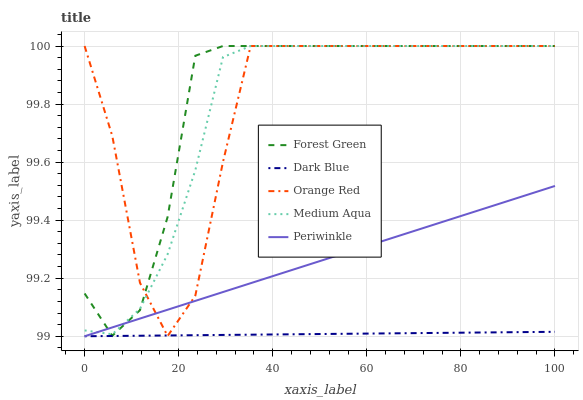Does Dark Blue have the minimum area under the curve?
Answer yes or no. Yes. Does Forest Green have the maximum area under the curve?
Answer yes or no. Yes. Does Forest Green have the minimum area under the curve?
Answer yes or no. No. Does Dark Blue have the maximum area under the curve?
Answer yes or no. No. Is Periwinkle the smoothest?
Answer yes or no. Yes. Is Orange Red the roughest?
Answer yes or no. Yes. Is Dark Blue the smoothest?
Answer yes or no. No. Is Dark Blue the roughest?
Answer yes or no. No. Does Periwinkle have the lowest value?
Answer yes or no. Yes. Does Forest Green have the lowest value?
Answer yes or no. No. Does Orange Red have the highest value?
Answer yes or no. Yes. Does Dark Blue have the highest value?
Answer yes or no. No. Is Dark Blue less than Forest Green?
Answer yes or no. Yes. Is Medium Aqua greater than Dark Blue?
Answer yes or no. Yes. Does Periwinkle intersect Orange Red?
Answer yes or no. Yes. Is Periwinkle less than Orange Red?
Answer yes or no. No. Is Periwinkle greater than Orange Red?
Answer yes or no. No. Does Dark Blue intersect Forest Green?
Answer yes or no. No. 